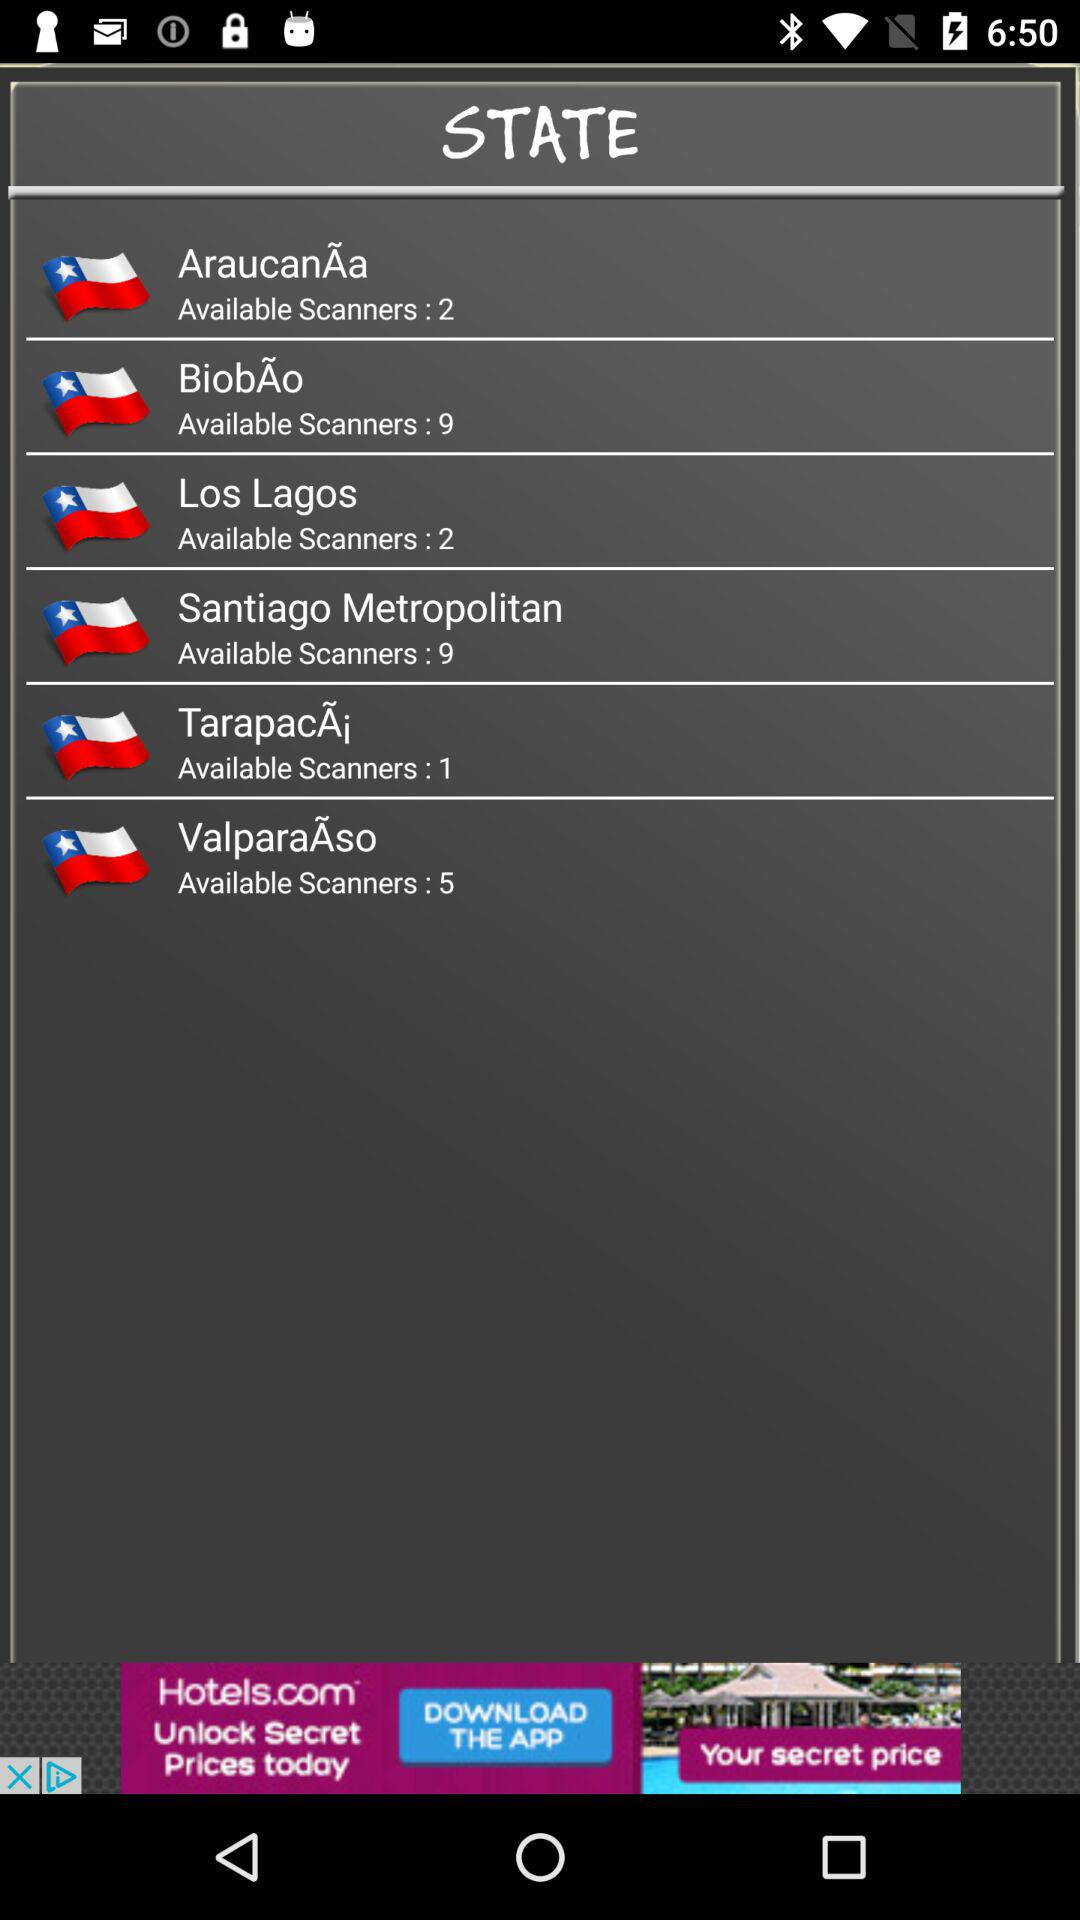How many scanners are available for ValparaÃso? There are 5 available scanners. 